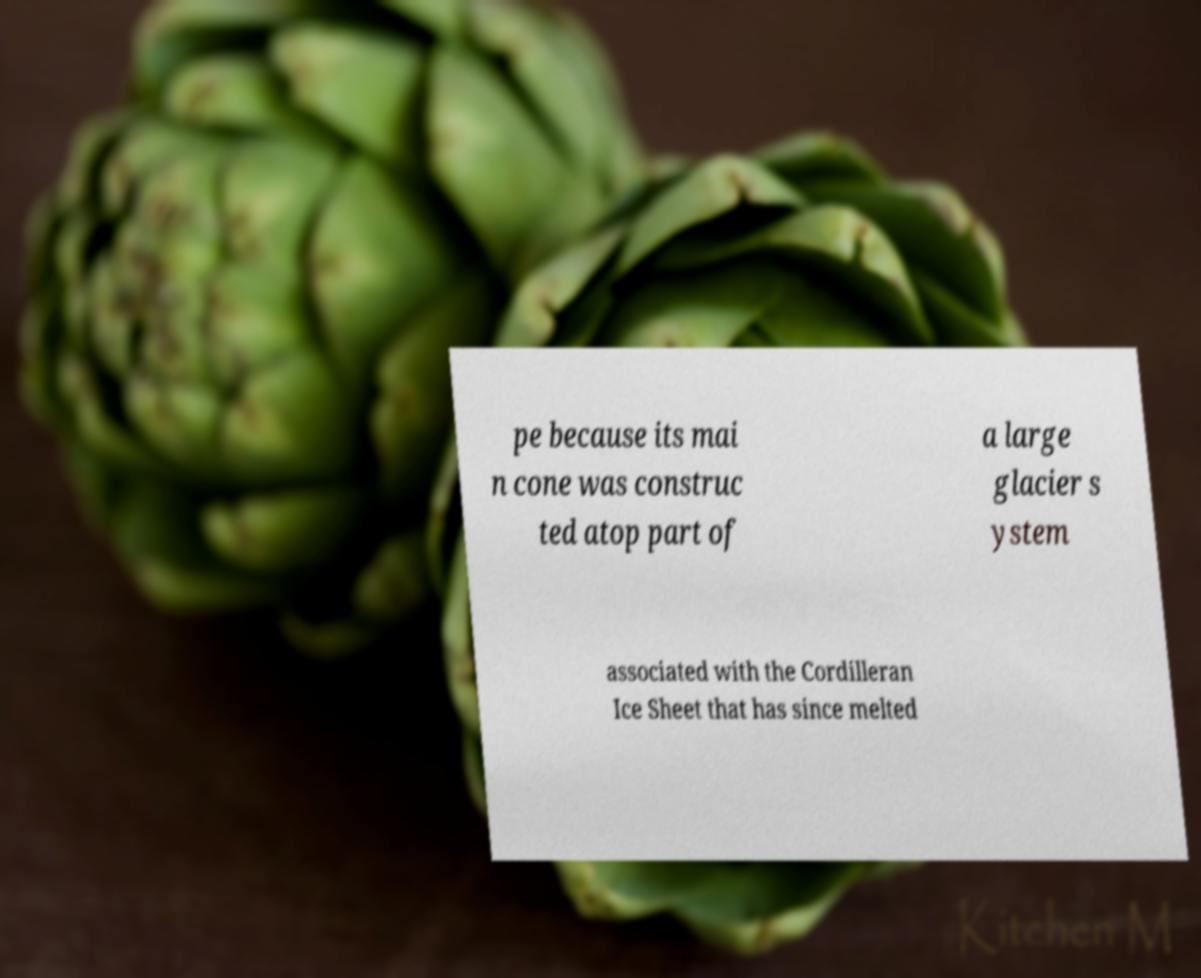For documentation purposes, I need the text within this image transcribed. Could you provide that? pe because its mai n cone was construc ted atop part of a large glacier s ystem associated with the Cordilleran Ice Sheet that has since melted 